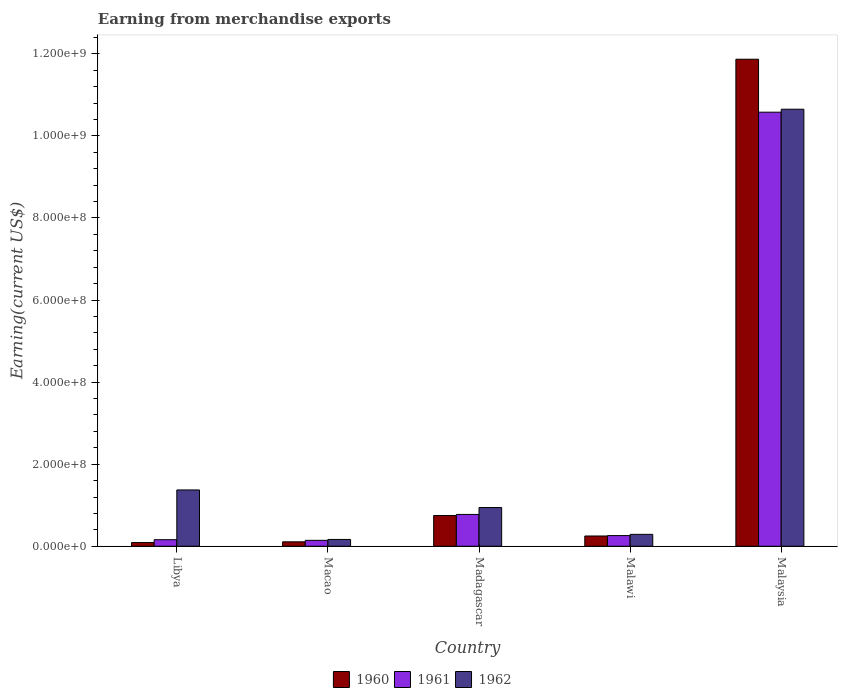How many groups of bars are there?
Your answer should be very brief. 5. Are the number of bars on each tick of the X-axis equal?
Provide a succinct answer. Yes. How many bars are there on the 2nd tick from the right?
Your answer should be very brief. 3. What is the label of the 4th group of bars from the left?
Give a very brief answer. Malawi. What is the amount earned from merchandise exports in 1962 in Malawi?
Provide a succinct answer. 2.90e+07. Across all countries, what is the maximum amount earned from merchandise exports in 1960?
Your response must be concise. 1.19e+09. Across all countries, what is the minimum amount earned from merchandise exports in 1962?
Provide a succinct answer. 1.66e+07. In which country was the amount earned from merchandise exports in 1960 maximum?
Offer a very short reply. Malaysia. In which country was the amount earned from merchandise exports in 1960 minimum?
Make the answer very short. Libya. What is the total amount earned from merchandise exports in 1962 in the graph?
Your answer should be very brief. 1.34e+09. What is the difference between the amount earned from merchandise exports in 1961 in Macao and that in Malawi?
Ensure brevity in your answer.  -1.16e+07. What is the difference between the amount earned from merchandise exports in 1962 in Malawi and the amount earned from merchandise exports in 1960 in Macao?
Give a very brief answer. 1.82e+07. What is the average amount earned from merchandise exports in 1961 per country?
Ensure brevity in your answer.  2.38e+08. What is the difference between the amount earned from merchandise exports of/in 1960 and amount earned from merchandise exports of/in 1961 in Macao?
Your answer should be very brief. -3.62e+06. In how many countries, is the amount earned from merchandise exports in 1962 greater than 40000000 US$?
Provide a short and direct response. 3. What is the ratio of the amount earned from merchandise exports in 1960 in Macao to that in Madagascar?
Your response must be concise. 0.14. Is the amount earned from merchandise exports in 1961 in Libya less than that in Malaysia?
Keep it short and to the point. Yes. What is the difference between the highest and the second highest amount earned from merchandise exports in 1961?
Ensure brevity in your answer.  9.80e+08. What is the difference between the highest and the lowest amount earned from merchandise exports in 1962?
Your response must be concise. 1.05e+09. What does the 2nd bar from the right in Malawi represents?
Your response must be concise. 1961. Is it the case that in every country, the sum of the amount earned from merchandise exports in 1961 and amount earned from merchandise exports in 1962 is greater than the amount earned from merchandise exports in 1960?
Give a very brief answer. Yes. How many countries are there in the graph?
Provide a short and direct response. 5. Does the graph contain grids?
Keep it short and to the point. No. What is the title of the graph?
Ensure brevity in your answer.  Earning from merchandise exports. Does "2003" appear as one of the legend labels in the graph?
Ensure brevity in your answer.  No. What is the label or title of the X-axis?
Ensure brevity in your answer.  Country. What is the label or title of the Y-axis?
Give a very brief answer. Earning(current US$). What is the Earning(current US$) of 1960 in Libya?
Provide a short and direct response. 8.96e+06. What is the Earning(current US$) of 1961 in Libya?
Offer a very short reply. 1.60e+07. What is the Earning(current US$) of 1962 in Libya?
Your response must be concise. 1.37e+08. What is the Earning(current US$) of 1960 in Macao?
Your answer should be very brief. 1.08e+07. What is the Earning(current US$) of 1961 in Macao?
Ensure brevity in your answer.  1.44e+07. What is the Earning(current US$) in 1962 in Macao?
Offer a very short reply. 1.66e+07. What is the Earning(current US$) in 1960 in Madagascar?
Provide a succinct answer. 7.49e+07. What is the Earning(current US$) of 1961 in Madagascar?
Provide a succinct answer. 7.75e+07. What is the Earning(current US$) of 1962 in Madagascar?
Give a very brief answer. 9.43e+07. What is the Earning(current US$) in 1960 in Malawi?
Keep it short and to the point. 2.50e+07. What is the Earning(current US$) in 1961 in Malawi?
Offer a very short reply. 2.60e+07. What is the Earning(current US$) of 1962 in Malawi?
Your answer should be compact. 2.90e+07. What is the Earning(current US$) in 1960 in Malaysia?
Your answer should be very brief. 1.19e+09. What is the Earning(current US$) in 1961 in Malaysia?
Your answer should be compact. 1.06e+09. What is the Earning(current US$) in 1962 in Malaysia?
Offer a terse response. 1.06e+09. Across all countries, what is the maximum Earning(current US$) in 1960?
Keep it short and to the point. 1.19e+09. Across all countries, what is the maximum Earning(current US$) of 1961?
Your response must be concise. 1.06e+09. Across all countries, what is the maximum Earning(current US$) in 1962?
Your answer should be very brief. 1.06e+09. Across all countries, what is the minimum Earning(current US$) of 1960?
Ensure brevity in your answer.  8.96e+06. Across all countries, what is the minimum Earning(current US$) of 1961?
Make the answer very short. 1.44e+07. Across all countries, what is the minimum Earning(current US$) in 1962?
Your answer should be very brief. 1.66e+07. What is the total Earning(current US$) in 1960 in the graph?
Your response must be concise. 1.31e+09. What is the total Earning(current US$) in 1961 in the graph?
Offer a very short reply. 1.19e+09. What is the total Earning(current US$) of 1962 in the graph?
Ensure brevity in your answer.  1.34e+09. What is the difference between the Earning(current US$) in 1960 in Libya and that in Macao?
Your response must be concise. -1.82e+06. What is the difference between the Earning(current US$) in 1961 in Libya and that in Macao?
Offer a terse response. 1.56e+06. What is the difference between the Earning(current US$) in 1962 in Libya and that in Macao?
Offer a terse response. 1.21e+08. What is the difference between the Earning(current US$) in 1960 in Libya and that in Madagascar?
Your response must be concise. -6.59e+07. What is the difference between the Earning(current US$) of 1961 in Libya and that in Madagascar?
Provide a succinct answer. -6.16e+07. What is the difference between the Earning(current US$) in 1962 in Libya and that in Madagascar?
Offer a terse response. 4.29e+07. What is the difference between the Earning(current US$) in 1960 in Libya and that in Malawi?
Your answer should be compact. -1.60e+07. What is the difference between the Earning(current US$) of 1961 in Libya and that in Malawi?
Provide a succinct answer. -1.00e+07. What is the difference between the Earning(current US$) in 1962 in Libya and that in Malawi?
Your answer should be very brief. 1.08e+08. What is the difference between the Earning(current US$) of 1960 in Libya and that in Malaysia?
Provide a short and direct response. -1.18e+09. What is the difference between the Earning(current US$) of 1961 in Libya and that in Malaysia?
Offer a terse response. -1.04e+09. What is the difference between the Earning(current US$) in 1962 in Libya and that in Malaysia?
Give a very brief answer. -9.28e+08. What is the difference between the Earning(current US$) of 1960 in Macao and that in Madagascar?
Offer a terse response. -6.41e+07. What is the difference between the Earning(current US$) in 1961 in Macao and that in Madagascar?
Keep it short and to the point. -6.31e+07. What is the difference between the Earning(current US$) of 1962 in Macao and that in Madagascar?
Offer a terse response. -7.78e+07. What is the difference between the Earning(current US$) of 1960 in Macao and that in Malawi?
Your answer should be very brief. -1.42e+07. What is the difference between the Earning(current US$) of 1961 in Macao and that in Malawi?
Provide a short and direct response. -1.16e+07. What is the difference between the Earning(current US$) of 1962 in Macao and that in Malawi?
Your response must be concise. -1.24e+07. What is the difference between the Earning(current US$) in 1960 in Macao and that in Malaysia?
Offer a very short reply. -1.18e+09. What is the difference between the Earning(current US$) of 1961 in Macao and that in Malaysia?
Ensure brevity in your answer.  -1.04e+09. What is the difference between the Earning(current US$) of 1962 in Macao and that in Malaysia?
Provide a succinct answer. -1.05e+09. What is the difference between the Earning(current US$) of 1960 in Madagascar and that in Malawi?
Provide a succinct answer. 4.99e+07. What is the difference between the Earning(current US$) in 1961 in Madagascar and that in Malawi?
Make the answer very short. 5.15e+07. What is the difference between the Earning(current US$) in 1962 in Madagascar and that in Malawi?
Offer a very short reply. 6.53e+07. What is the difference between the Earning(current US$) of 1960 in Madagascar and that in Malaysia?
Your answer should be compact. -1.11e+09. What is the difference between the Earning(current US$) of 1961 in Madagascar and that in Malaysia?
Offer a very short reply. -9.80e+08. What is the difference between the Earning(current US$) in 1962 in Madagascar and that in Malaysia?
Your response must be concise. -9.71e+08. What is the difference between the Earning(current US$) of 1960 in Malawi and that in Malaysia?
Make the answer very short. -1.16e+09. What is the difference between the Earning(current US$) in 1961 in Malawi and that in Malaysia?
Offer a very short reply. -1.03e+09. What is the difference between the Earning(current US$) in 1962 in Malawi and that in Malaysia?
Your response must be concise. -1.04e+09. What is the difference between the Earning(current US$) in 1960 in Libya and the Earning(current US$) in 1961 in Macao?
Your answer should be compact. -5.44e+06. What is the difference between the Earning(current US$) of 1960 in Libya and the Earning(current US$) of 1962 in Macao?
Provide a short and direct response. -7.62e+06. What is the difference between the Earning(current US$) in 1961 in Libya and the Earning(current US$) in 1962 in Macao?
Make the answer very short. -6.20e+05. What is the difference between the Earning(current US$) in 1960 in Libya and the Earning(current US$) in 1961 in Madagascar?
Your answer should be compact. -6.86e+07. What is the difference between the Earning(current US$) in 1960 in Libya and the Earning(current US$) in 1962 in Madagascar?
Give a very brief answer. -8.54e+07. What is the difference between the Earning(current US$) in 1961 in Libya and the Earning(current US$) in 1962 in Madagascar?
Make the answer very short. -7.84e+07. What is the difference between the Earning(current US$) in 1960 in Libya and the Earning(current US$) in 1961 in Malawi?
Your answer should be compact. -1.70e+07. What is the difference between the Earning(current US$) in 1960 in Libya and the Earning(current US$) in 1962 in Malawi?
Offer a terse response. -2.00e+07. What is the difference between the Earning(current US$) of 1961 in Libya and the Earning(current US$) of 1962 in Malawi?
Give a very brief answer. -1.30e+07. What is the difference between the Earning(current US$) in 1960 in Libya and the Earning(current US$) in 1961 in Malaysia?
Make the answer very short. -1.05e+09. What is the difference between the Earning(current US$) of 1960 in Libya and the Earning(current US$) of 1962 in Malaysia?
Provide a succinct answer. -1.06e+09. What is the difference between the Earning(current US$) in 1961 in Libya and the Earning(current US$) in 1962 in Malaysia?
Offer a terse response. -1.05e+09. What is the difference between the Earning(current US$) of 1960 in Macao and the Earning(current US$) of 1961 in Madagascar?
Keep it short and to the point. -6.67e+07. What is the difference between the Earning(current US$) in 1960 in Macao and the Earning(current US$) in 1962 in Madagascar?
Your response must be concise. -8.36e+07. What is the difference between the Earning(current US$) in 1961 in Macao and the Earning(current US$) in 1962 in Madagascar?
Give a very brief answer. -7.99e+07. What is the difference between the Earning(current US$) in 1960 in Macao and the Earning(current US$) in 1961 in Malawi?
Offer a very short reply. -1.52e+07. What is the difference between the Earning(current US$) of 1960 in Macao and the Earning(current US$) of 1962 in Malawi?
Your answer should be very brief. -1.82e+07. What is the difference between the Earning(current US$) in 1961 in Macao and the Earning(current US$) in 1962 in Malawi?
Your answer should be compact. -1.46e+07. What is the difference between the Earning(current US$) in 1960 in Macao and the Earning(current US$) in 1961 in Malaysia?
Keep it short and to the point. -1.05e+09. What is the difference between the Earning(current US$) in 1960 in Macao and the Earning(current US$) in 1962 in Malaysia?
Your response must be concise. -1.05e+09. What is the difference between the Earning(current US$) in 1961 in Macao and the Earning(current US$) in 1962 in Malaysia?
Provide a short and direct response. -1.05e+09. What is the difference between the Earning(current US$) of 1960 in Madagascar and the Earning(current US$) of 1961 in Malawi?
Provide a succinct answer. 4.89e+07. What is the difference between the Earning(current US$) of 1960 in Madagascar and the Earning(current US$) of 1962 in Malawi?
Provide a short and direct response. 4.59e+07. What is the difference between the Earning(current US$) in 1961 in Madagascar and the Earning(current US$) in 1962 in Malawi?
Give a very brief answer. 4.85e+07. What is the difference between the Earning(current US$) in 1960 in Madagascar and the Earning(current US$) in 1961 in Malaysia?
Ensure brevity in your answer.  -9.83e+08. What is the difference between the Earning(current US$) in 1960 in Madagascar and the Earning(current US$) in 1962 in Malaysia?
Provide a short and direct response. -9.90e+08. What is the difference between the Earning(current US$) in 1961 in Madagascar and the Earning(current US$) in 1962 in Malaysia?
Offer a very short reply. -9.87e+08. What is the difference between the Earning(current US$) in 1960 in Malawi and the Earning(current US$) in 1961 in Malaysia?
Keep it short and to the point. -1.03e+09. What is the difference between the Earning(current US$) in 1960 in Malawi and the Earning(current US$) in 1962 in Malaysia?
Provide a short and direct response. -1.04e+09. What is the difference between the Earning(current US$) in 1961 in Malawi and the Earning(current US$) in 1962 in Malaysia?
Make the answer very short. -1.04e+09. What is the average Earning(current US$) in 1960 per country?
Provide a succinct answer. 2.61e+08. What is the average Earning(current US$) of 1961 per country?
Give a very brief answer. 2.38e+08. What is the average Earning(current US$) in 1962 per country?
Your answer should be compact. 2.68e+08. What is the difference between the Earning(current US$) of 1960 and Earning(current US$) of 1961 in Libya?
Offer a very short reply. -7.00e+06. What is the difference between the Earning(current US$) in 1960 and Earning(current US$) in 1962 in Libya?
Give a very brief answer. -1.28e+08. What is the difference between the Earning(current US$) of 1961 and Earning(current US$) of 1962 in Libya?
Ensure brevity in your answer.  -1.21e+08. What is the difference between the Earning(current US$) of 1960 and Earning(current US$) of 1961 in Macao?
Ensure brevity in your answer.  -3.62e+06. What is the difference between the Earning(current US$) of 1960 and Earning(current US$) of 1962 in Macao?
Your answer should be very brief. -5.80e+06. What is the difference between the Earning(current US$) in 1961 and Earning(current US$) in 1962 in Macao?
Provide a succinct answer. -2.18e+06. What is the difference between the Earning(current US$) of 1960 and Earning(current US$) of 1961 in Madagascar?
Make the answer very short. -2.65e+06. What is the difference between the Earning(current US$) in 1960 and Earning(current US$) in 1962 in Madagascar?
Offer a terse response. -1.94e+07. What is the difference between the Earning(current US$) in 1961 and Earning(current US$) in 1962 in Madagascar?
Your answer should be very brief. -1.68e+07. What is the difference between the Earning(current US$) in 1960 and Earning(current US$) in 1961 in Malawi?
Give a very brief answer. -1.00e+06. What is the difference between the Earning(current US$) of 1960 and Earning(current US$) of 1962 in Malawi?
Ensure brevity in your answer.  -4.00e+06. What is the difference between the Earning(current US$) in 1960 and Earning(current US$) in 1961 in Malaysia?
Provide a succinct answer. 1.29e+08. What is the difference between the Earning(current US$) of 1960 and Earning(current US$) of 1962 in Malaysia?
Keep it short and to the point. 1.22e+08. What is the difference between the Earning(current US$) in 1961 and Earning(current US$) in 1962 in Malaysia?
Make the answer very short. -7.18e+06. What is the ratio of the Earning(current US$) in 1960 in Libya to that in Macao?
Offer a terse response. 0.83. What is the ratio of the Earning(current US$) in 1961 in Libya to that in Macao?
Keep it short and to the point. 1.11. What is the ratio of the Earning(current US$) of 1962 in Libya to that in Macao?
Give a very brief answer. 8.28. What is the ratio of the Earning(current US$) of 1960 in Libya to that in Madagascar?
Ensure brevity in your answer.  0.12. What is the ratio of the Earning(current US$) in 1961 in Libya to that in Madagascar?
Make the answer very short. 0.21. What is the ratio of the Earning(current US$) in 1962 in Libya to that in Madagascar?
Give a very brief answer. 1.45. What is the ratio of the Earning(current US$) of 1960 in Libya to that in Malawi?
Ensure brevity in your answer.  0.36. What is the ratio of the Earning(current US$) in 1961 in Libya to that in Malawi?
Your answer should be compact. 0.61. What is the ratio of the Earning(current US$) of 1962 in Libya to that in Malawi?
Offer a terse response. 4.73. What is the ratio of the Earning(current US$) of 1960 in Libya to that in Malaysia?
Provide a short and direct response. 0.01. What is the ratio of the Earning(current US$) in 1961 in Libya to that in Malaysia?
Offer a terse response. 0.02. What is the ratio of the Earning(current US$) in 1962 in Libya to that in Malaysia?
Give a very brief answer. 0.13. What is the ratio of the Earning(current US$) in 1960 in Macao to that in Madagascar?
Ensure brevity in your answer.  0.14. What is the ratio of the Earning(current US$) of 1961 in Macao to that in Madagascar?
Ensure brevity in your answer.  0.19. What is the ratio of the Earning(current US$) in 1962 in Macao to that in Madagascar?
Ensure brevity in your answer.  0.18. What is the ratio of the Earning(current US$) of 1960 in Macao to that in Malawi?
Offer a very short reply. 0.43. What is the ratio of the Earning(current US$) of 1961 in Macao to that in Malawi?
Provide a short and direct response. 0.55. What is the ratio of the Earning(current US$) in 1962 in Macao to that in Malawi?
Offer a very short reply. 0.57. What is the ratio of the Earning(current US$) of 1960 in Macao to that in Malaysia?
Your answer should be very brief. 0.01. What is the ratio of the Earning(current US$) of 1961 in Macao to that in Malaysia?
Provide a short and direct response. 0.01. What is the ratio of the Earning(current US$) in 1962 in Macao to that in Malaysia?
Ensure brevity in your answer.  0.02. What is the ratio of the Earning(current US$) in 1960 in Madagascar to that in Malawi?
Provide a succinct answer. 3. What is the ratio of the Earning(current US$) of 1961 in Madagascar to that in Malawi?
Give a very brief answer. 2.98. What is the ratio of the Earning(current US$) in 1962 in Madagascar to that in Malawi?
Provide a succinct answer. 3.25. What is the ratio of the Earning(current US$) of 1960 in Madagascar to that in Malaysia?
Ensure brevity in your answer.  0.06. What is the ratio of the Earning(current US$) of 1961 in Madagascar to that in Malaysia?
Offer a very short reply. 0.07. What is the ratio of the Earning(current US$) of 1962 in Madagascar to that in Malaysia?
Your answer should be compact. 0.09. What is the ratio of the Earning(current US$) of 1960 in Malawi to that in Malaysia?
Keep it short and to the point. 0.02. What is the ratio of the Earning(current US$) of 1961 in Malawi to that in Malaysia?
Keep it short and to the point. 0.02. What is the ratio of the Earning(current US$) of 1962 in Malawi to that in Malaysia?
Offer a terse response. 0.03. What is the difference between the highest and the second highest Earning(current US$) in 1960?
Give a very brief answer. 1.11e+09. What is the difference between the highest and the second highest Earning(current US$) in 1961?
Provide a succinct answer. 9.80e+08. What is the difference between the highest and the second highest Earning(current US$) of 1962?
Your answer should be compact. 9.28e+08. What is the difference between the highest and the lowest Earning(current US$) of 1960?
Your response must be concise. 1.18e+09. What is the difference between the highest and the lowest Earning(current US$) in 1961?
Ensure brevity in your answer.  1.04e+09. What is the difference between the highest and the lowest Earning(current US$) in 1962?
Offer a very short reply. 1.05e+09. 